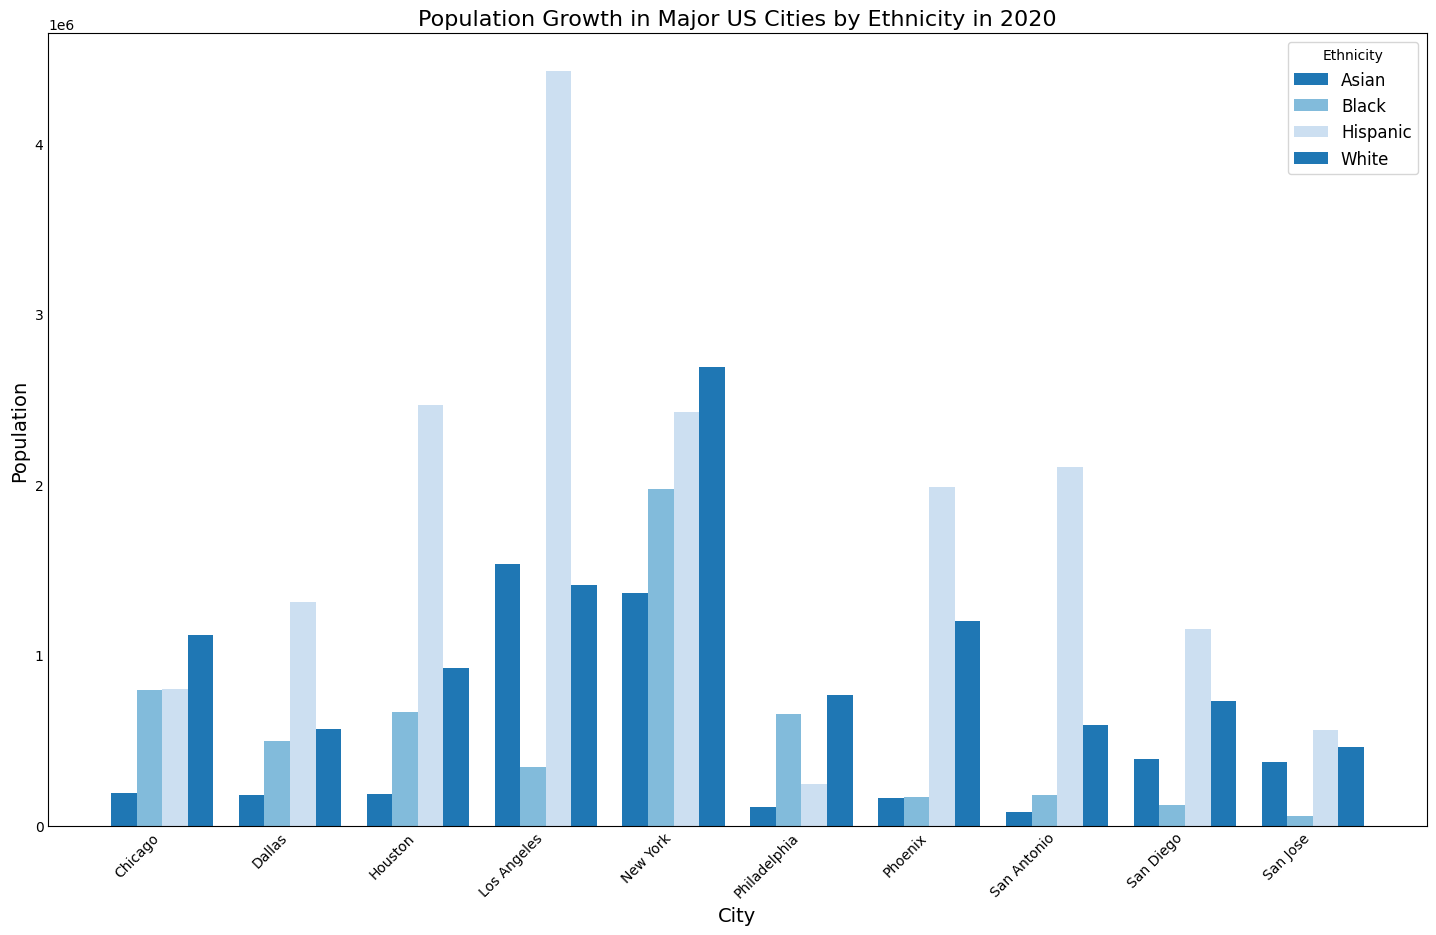Which city has the highest total population across all ethnicities in 2020? To find the city with the highest total population, sum the populations of all ethnicities for each city and compare the totals. Los Angeles has the highest total with a combined population of 7,174,000.
Answer: Los Angeles Which city has the smallest population of Asian residents? Look at the bar heights representing the Asian population for each city. San Antonio has the smallest Asian population with 83,000.
Answer: San Antonio What is the difference in Hispanic population between New York and Los Angeles? Subtract the Hispanic population of Los Angeles from that of New York: 4,422,000 (Los Angeles) - 2,422,000 (New York) = 2,000,000.
Answer: 2,000,000 How does the Black population in Philadelphia compare to that in Chicago? Compare the bar heights for the Black population in Philadelphia and Chicago. Philadelphia has 654,000 and Chicago has 795,000. Philadelphia's Black population is smaller.
Answer: Smaller For which ethnicity does Houston have the highest population among the listed ethnicities? Compare the bar heights for all ethnicities within Houston. The Hispanic population in Houston is the highest among the listed ethnicities, with 2,463,000.
Answer: Hispanic What is the combined population of White and Hispanic residents in San Diego? Sum the population of White and Hispanic residents in San Diego: 728,000 (White) + 1,154,000 (Hispanic) = 1,882,000.
Answer: 1,882,000 Among the cities listed, which city has the second-highest Asian population? Arrange the Asian populations in descending order and identify the second-highest. New York has the highest (1,365,000), and Los Angeles has the second-highest, with 1,533,000.
Answer: Los Angeles Which city's White population is closest to 600,000? Check the White population bar heights and values to find which one is closest to 600,000. San Antonio has a White population of 590,000, which is the closest.
Answer: San Antonio What is the average population of the Black residents in all the listed cities? Sum the Black population in all the cities and divide by the number of cities: (1,973,000 + 346,000 + 795,000 + 667,000 + 168,000 + 654,000 + 177,000 + 123,000 + 497,000 + 55,000) / 10 = 545,500.
Answer: 545,500 Compare the total populations of New York and Chicago. Which is greater, and by how much? Sum the populations for each ethnicity in New York and Chicago, then subtract the total population of Chicago from that of New York. New York's total is 8,443,000, and Chicago's is 2,800,000. The difference is 8,443,000 - 2,800,000 = 5,643,000.
Answer: New York, 5,643,000 